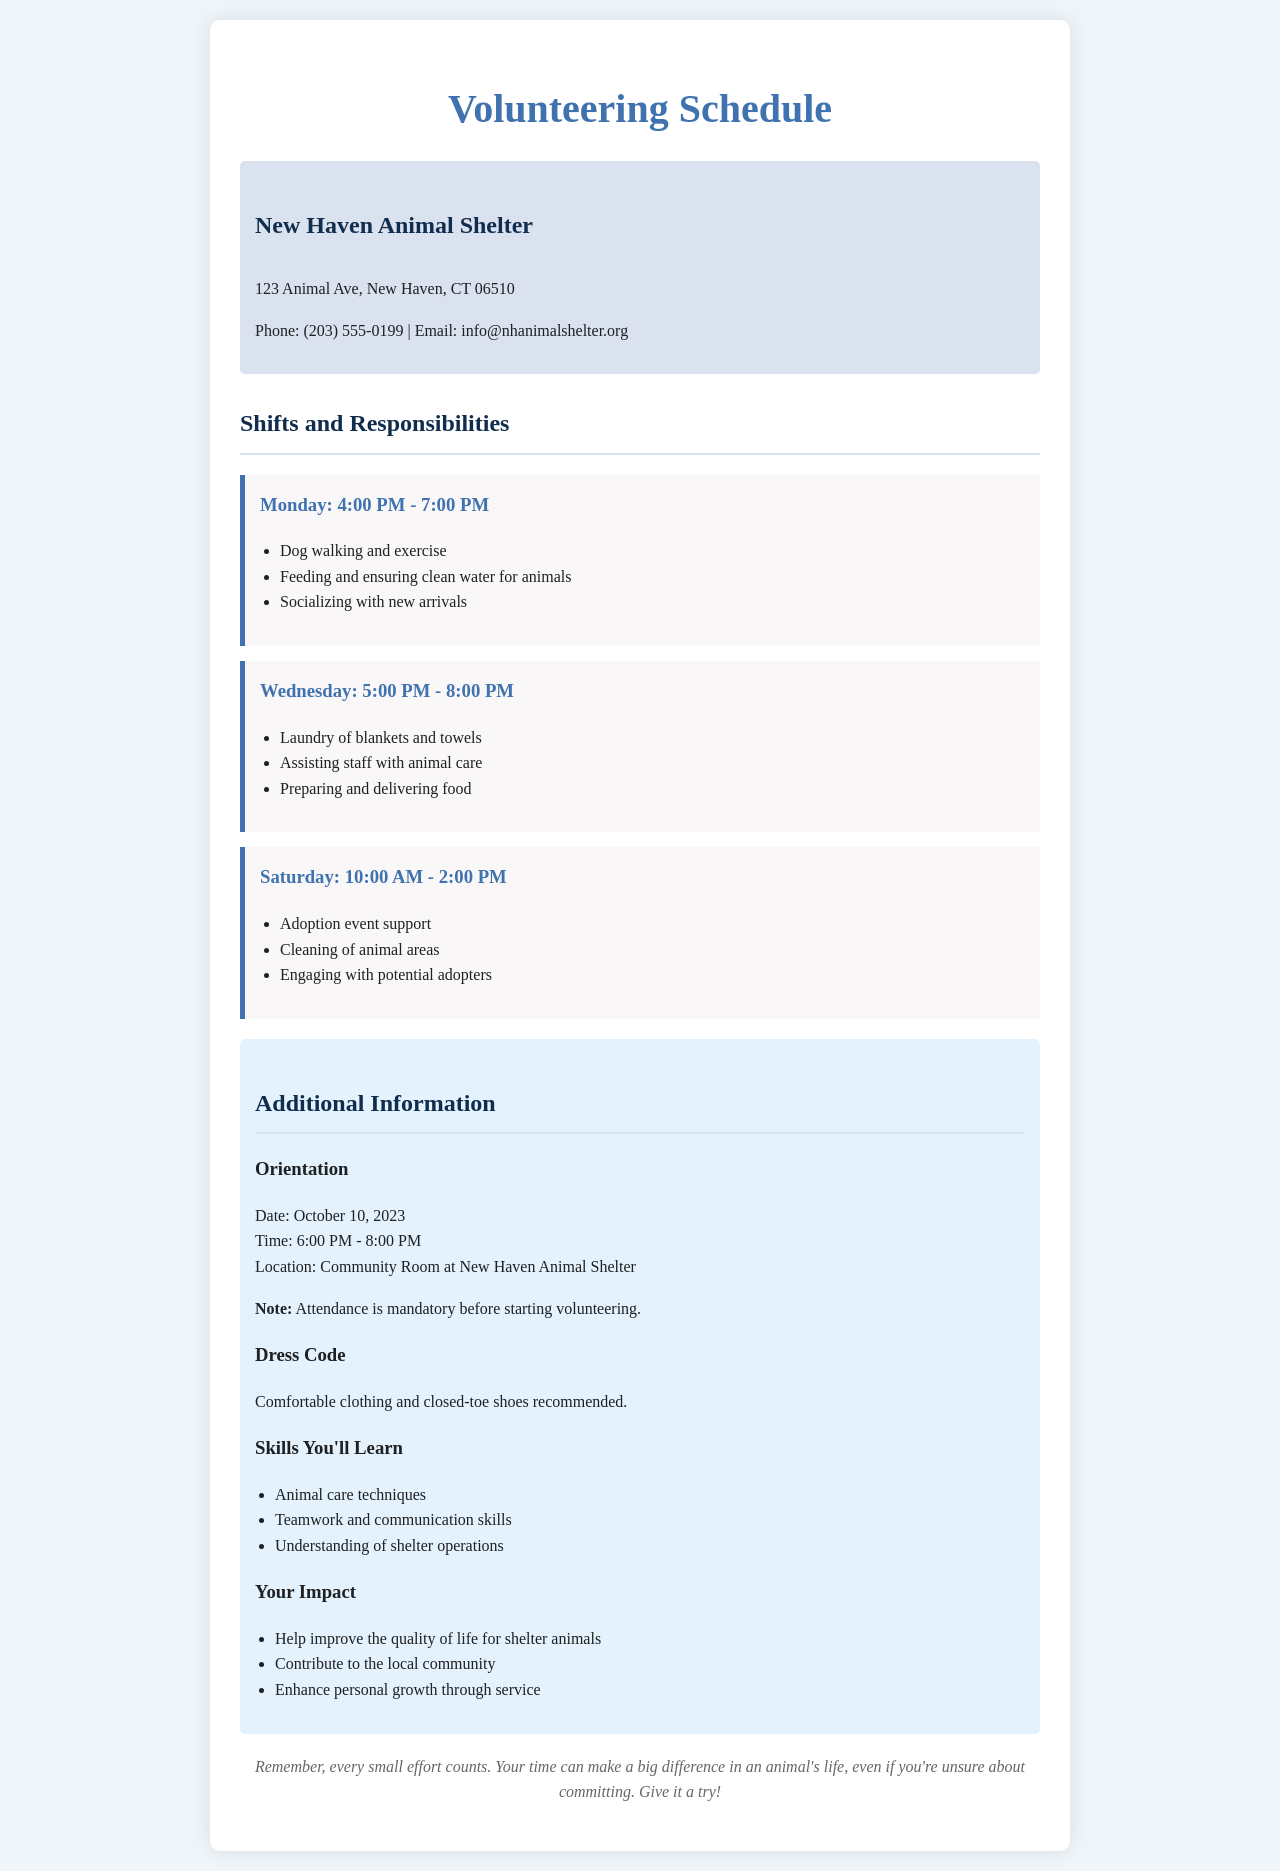What is the name of the shelter? The shelter's name is mentioned at the beginning of the document as "New Haven Animal Shelter."
Answer: New Haven Animal Shelter What are the operating hours on Saturday? The document specifies the operating hours for Saturday as "10:00 AM - 2:00 PM."
Answer: 10:00 AM - 2:00 PM What should volunteers wear? The document advises volunteers to wear "comfortable clothing and closed-toe shoes."
Answer: Comfortable clothing and closed-toe shoes When is the orientation date? The orientation date is provided in the document as "October 10, 2023."
Answer: October 10, 2023 What is one responsibility on Monday? The document lists several tasks, and one of them is "Dog walking and exercise."
Answer: Dog walking and exercise How many shifts are mentioned in the schedule? The schedule outlines three shifts in total for different days.
Answer: Three shifts What skill can volunteers learn related to teamwork? The document lists "Teamwork and communication skills" as a learned skill.
Answer: Teamwork and communication skills Is attendance at the orientation optional? The document states that "Attendance is mandatory before starting volunteering."
Answer: Mandatory How can volunteers contribute to the local community? The document highlights that volunteers can "Contribute to the local community."
Answer: Contribute to the local community 